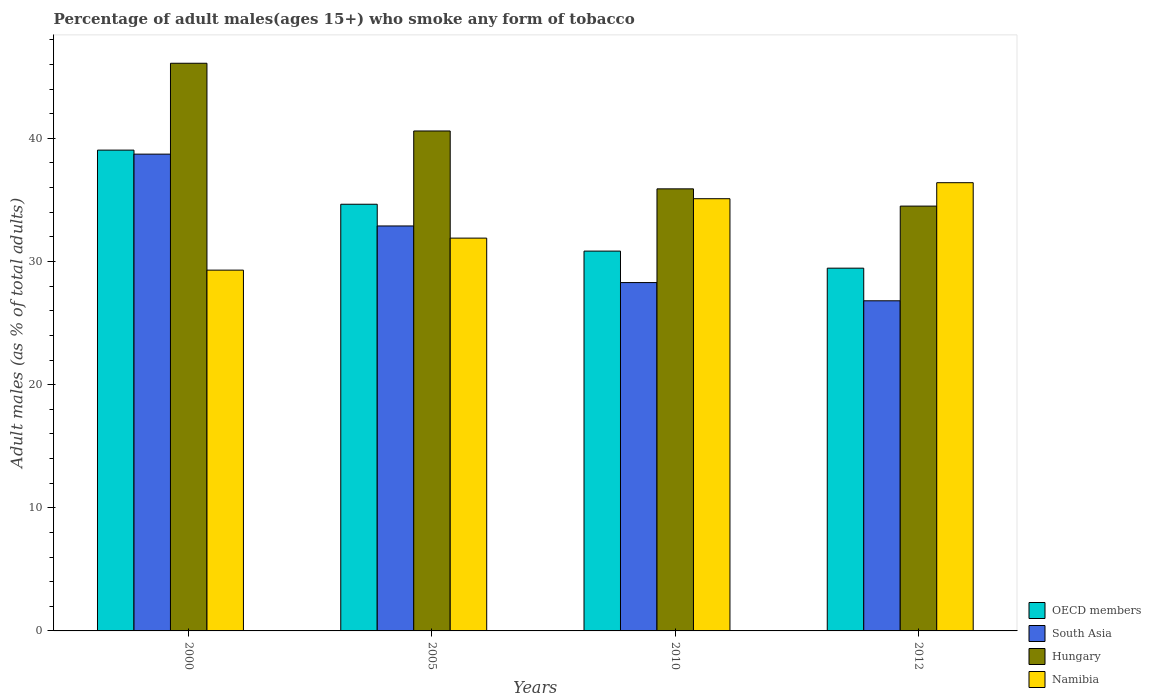Are the number of bars per tick equal to the number of legend labels?
Make the answer very short. Yes. How many bars are there on the 4th tick from the left?
Make the answer very short. 4. How many bars are there on the 3rd tick from the right?
Make the answer very short. 4. What is the label of the 2nd group of bars from the left?
Ensure brevity in your answer.  2005. In how many cases, is the number of bars for a given year not equal to the number of legend labels?
Offer a terse response. 0. What is the percentage of adult males who smoke in South Asia in 2012?
Your answer should be very brief. 26.81. Across all years, what is the maximum percentage of adult males who smoke in Namibia?
Make the answer very short. 36.4. Across all years, what is the minimum percentage of adult males who smoke in Hungary?
Provide a succinct answer. 34.5. In which year was the percentage of adult males who smoke in OECD members maximum?
Offer a terse response. 2000. What is the total percentage of adult males who smoke in Namibia in the graph?
Give a very brief answer. 132.7. What is the difference between the percentage of adult males who smoke in Hungary in 2010 and that in 2012?
Give a very brief answer. 1.4. What is the difference between the percentage of adult males who smoke in OECD members in 2000 and the percentage of adult males who smoke in Namibia in 2005?
Offer a very short reply. 7.15. What is the average percentage of adult males who smoke in OECD members per year?
Give a very brief answer. 33.5. In the year 2012, what is the difference between the percentage of adult males who smoke in South Asia and percentage of adult males who smoke in Hungary?
Provide a short and direct response. -7.69. In how many years, is the percentage of adult males who smoke in South Asia greater than 22 %?
Your answer should be very brief. 4. What is the ratio of the percentage of adult males who smoke in Hungary in 2010 to that in 2012?
Offer a very short reply. 1.04. Is the percentage of adult males who smoke in OECD members in 2000 less than that in 2012?
Provide a succinct answer. No. What is the difference between the highest and the second highest percentage of adult males who smoke in OECD members?
Your answer should be compact. 4.4. What is the difference between the highest and the lowest percentage of adult males who smoke in South Asia?
Offer a very short reply. 11.91. Is the sum of the percentage of adult males who smoke in OECD members in 2005 and 2012 greater than the maximum percentage of adult males who smoke in Hungary across all years?
Provide a succinct answer. Yes. Is it the case that in every year, the sum of the percentage of adult males who smoke in OECD members and percentage of adult males who smoke in South Asia is greater than the sum of percentage of adult males who smoke in Namibia and percentage of adult males who smoke in Hungary?
Your answer should be compact. No. What does the 3rd bar from the left in 2000 represents?
Your response must be concise. Hungary. What does the 3rd bar from the right in 2010 represents?
Your answer should be very brief. South Asia. How many bars are there?
Your response must be concise. 16. What is the difference between two consecutive major ticks on the Y-axis?
Give a very brief answer. 10. Does the graph contain any zero values?
Give a very brief answer. No. What is the title of the graph?
Provide a succinct answer. Percentage of adult males(ages 15+) who smoke any form of tobacco. What is the label or title of the X-axis?
Your answer should be compact. Years. What is the label or title of the Y-axis?
Offer a terse response. Adult males (as % of total adults). What is the Adult males (as % of total adults) in OECD members in 2000?
Provide a succinct answer. 39.05. What is the Adult males (as % of total adults) of South Asia in 2000?
Keep it short and to the point. 38.72. What is the Adult males (as % of total adults) of Hungary in 2000?
Provide a succinct answer. 46.1. What is the Adult males (as % of total adults) of Namibia in 2000?
Give a very brief answer. 29.3. What is the Adult males (as % of total adults) of OECD members in 2005?
Provide a short and direct response. 34.65. What is the Adult males (as % of total adults) in South Asia in 2005?
Your answer should be compact. 32.89. What is the Adult males (as % of total adults) in Hungary in 2005?
Your response must be concise. 40.6. What is the Adult males (as % of total adults) of Namibia in 2005?
Offer a terse response. 31.9. What is the Adult males (as % of total adults) of OECD members in 2010?
Offer a terse response. 30.85. What is the Adult males (as % of total adults) in South Asia in 2010?
Offer a very short reply. 28.29. What is the Adult males (as % of total adults) of Hungary in 2010?
Make the answer very short. 35.9. What is the Adult males (as % of total adults) of Namibia in 2010?
Offer a very short reply. 35.1. What is the Adult males (as % of total adults) in OECD members in 2012?
Ensure brevity in your answer.  29.46. What is the Adult males (as % of total adults) in South Asia in 2012?
Keep it short and to the point. 26.81. What is the Adult males (as % of total adults) in Hungary in 2012?
Offer a very short reply. 34.5. What is the Adult males (as % of total adults) of Namibia in 2012?
Your answer should be very brief. 36.4. Across all years, what is the maximum Adult males (as % of total adults) of OECD members?
Keep it short and to the point. 39.05. Across all years, what is the maximum Adult males (as % of total adults) of South Asia?
Provide a short and direct response. 38.72. Across all years, what is the maximum Adult males (as % of total adults) in Hungary?
Your answer should be compact. 46.1. Across all years, what is the maximum Adult males (as % of total adults) in Namibia?
Give a very brief answer. 36.4. Across all years, what is the minimum Adult males (as % of total adults) of OECD members?
Offer a very short reply. 29.46. Across all years, what is the minimum Adult males (as % of total adults) of South Asia?
Offer a very short reply. 26.81. Across all years, what is the minimum Adult males (as % of total adults) of Hungary?
Make the answer very short. 34.5. Across all years, what is the minimum Adult males (as % of total adults) of Namibia?
Your response must be concise. 29.3. What is the total Adult males (as % of total adults) of OECD members in the graph?
Provide a succinct answer. 134. What is the total Adult males (as % of total adults) of South Asia in the graph?
Ensure brevity in your answer.  126.71. What is the total Adult males (as % of total adults) in Hungary in the graph?
Your answer should be compact. 157.1. What is the total Adult males (as % of total adults) of Namibia in the graph?
Offer a terse response. 132.7. What is the difference between the Adult males (as % of total adults) in OECD members in 2000 and that in 2005?
Provide a short and direct response. 4.4. What is the difference between the Adult males (as % of total adults) of South Asia in 2000 and that in 2005?
Ensure brevity in your answer.  5.83. What is the difference between the Adult males (as % of total adults) in Namibia in 2000 and that in 2005?
Your response must be concise. -2.6. What is the difference between the Adult males (as % of total adults) of OECD members in 2000 and that in 2010?
Your answer should be compact. 8.2. What is the difference between the Adult males (as % of total adults) of South Asia in 2000 and that in 2010?
Make the answer very short. 10.43. What is the difference between the Adult males (as % of total adults) of OECD members in 2000 and that in 2012?
Ensure brevity in your answer.  9.59. What is the difference between the Adult males (as % of total adults) in South Asia in 2000 and that in 2012?
Keep it short and to the point. 11.91. What is the difference between the Adult males (as % of total adults) of Hungary in 2000 and that in 2012?
Give a very brief answer. 11.6. What is the difference between the Adult males (as % of total adults) in OECD members in 2005 and that in 2010?
Make the answer very short. 3.81. What is the difference between the Adult males (as % of total adults) in South Asia in 2005 and that in 2010?
Your answer should be very brief. 4.6. What is the difference between the Adult males (as % of total adults) of Hungary in 2005 and that in 2010?
Keep it short and to the point. 4.7. What is the difference between the Adult males (as % of total adults) in OECD members in 2005 and that in 2012?
Ensure brevity in your answer.  5.19. What is the difference between the Adult males (as % of total adults) in South Asia in 2005 and that in 2012?
Offer a terse response. 6.08. What is the difference between the Adult males (as % of total adults) in Hungary in 2005 and that in 2012?
Offer a very short reply. 6.1. What is the difference between the Adult males (as % of total adults) in OECD members in 2010 and that in 2012?
Your answer should be very brief. 1.39. What is the difference between the Adult males (as % of total adults) of South Asia in 2010 and that in 2012?
Provide a succinct answer. 1.48. What is the difference between the Adult males (as % of total adults) in Namibia in 2010 and that in 2012?
Keep it short and to the point. -1.3. What is the difference between the Adult males (as % of total adults) in OECD members in 2000 and the Adult males (as % of total adults) in South Asia in 2005?
Your answer should be compact. 6.16. What is the difference between the Adult males (as % of total adults) of OECD members in 2000 and the Adult males (as % of total adults) of Hungary in 2005?
Make the answer very short. -1.55. What is the difference between the Adult males (as % of total adults) in OECD members in 2000 and the Adult males (as % of total adults) in Namibia in 2005?
Your answer should be compact. 7.15. What is the difference between the Adult males (as % of total adults) in South Asia in 2000 and the Adult males (as % of total adults) in Hungary in 2005?
Provide a short and direct response. -1.88. What is the difference between the Adult males (as % of total adults) in South Asia in 2000 and the Adult males (as % of total adults) in Namibia in 2005?
Keep it short and to the point. 6.82. What is the difference between the Adult males (as % of total adults) in Hungary in 2000 and the Adult males (as % of total adults) in Namibia in 2005?
Provide a succinct answer. 14.2. What is the difference between the Adult males (as % of total adults) of OECD members in 2000 and the Adult males (as % of total adults) of South Asia in 2010?
Provide a succinct answer. 10.76. What is the difference between the Adult males (as % of total adults) of OECD members in 2000 and the Adult males (as % of total adults) of Hungary in 2010?
Ensure brevity in your answer.  3.15. What is the difference between the Adult males (as % of total adults) in OECD members in 2000 and the Adult males (as % of total adults) in Namibia in 2010?
Provide a succinct answer. 3.95. What is the difference between the Adult males (as % of total adults) of South Asia in 2000 and the Adult males (as % of total adults) of Hungary in 2010?
Your answer should be compact. 2.82. What is the difference between the Adult males (as % of total adults) of South Asia in 2000 and the Adult males (as % of total adults) of Namibia in 2010?
Ensure brevity in your answer.  3.62. What is the difference between the Adult males (as % of total adults) in OECD members in 2000 and the Adult males (as % of total adults) in South Asia in 2012?
Offer a very short reply. 12.24. What is the difference between the Adult males (as % of total adults) in OECD members in 2000 and the Adult males (as % of total adults) in Hungary in 2012?
Your answer should be compact. 4.55. What is the difference between the Adult males (as % of total adults) in OECD members in 2000 and the Adult males (as % of total adults) in Namibia in 2012?
Keep it short and to the point. 2.65. What is the difference between the Adult males (as % of total adults) of South Asia in 2000 and the Adult males (as % of total adults) of Hungary in 2012?
Offer a very short reply. 4.22. What is the difference between the Adult males (as % of total adults) in South Asia in 2000 and the Adult males (as % of total adults) in Namibia in 2012?
Give a very brief answer. 2.32. What is the difference between the Adult males (as % of total adults) of OECD members in 2005 and the Adult males (as % of total adults) of South Asia in 2010?
Ensure brevity in your answer.  6.36. What is the difference between the Adult males (as % of total adults) in OECD members in 2005 and the Adult males (as % of total adults) in Hungary in 2010?
Offer a terse response. -1.25. What is the difference between the Adult males (as % of total adults) of OECD members in 2005 and the Adult males (as % of total adults) of Namibia in 2010?
Ensure brevity in your answer.  -0.45. What is the difference between the Adult males (as % of total adults) in South Asia in 2005 and the Adult males (as % of total adults) in Hungary in 2010?
Give a very brief answer. -3.01. What is the difference between the Adult males (as % of total adults) of South Asia in 2005 and the Adult males (as % of total adults) of Namibia in 2010?
Give a very brief answer. -2.21. What is the difference between the Adult males (as % of total adults) in OECD members in 2005 and the Adult males (as % of total adults) in South Asia in 2012?
Give a very brief answer. 7.84. What is the difference between the Adult males (as % of total adults) of OECD members in 2005 and the Adult males (as % of total adults) of Hungary in 2012?
Offer a terse response. 0.15. What is the difference between the Adult males (as % of total adults) of OECD members in 2005 and the Adult males (as % of total adults) of Namibia in 2012?
Ensure brevity in your answer.  -1.75. What is the difference between the Adult males (as % of total adults) in South Asia in 2005 and the Adult males (as % of total adults) in Hungary in 2012?
Your response must be concise. -1.61. What is the difference between the Adult males (as % of total adults) in South Asia in 2005 and the Adult males (as % of total adults) in Namibia in 2012?
Provide a short and direct response. -3.51. What is the difference between the Adult males (as % of total adults) of Hungary in 2005 and the Adult males (as % of total adults) of Namibia in 2012?
Make the answer very short. 4.2. What is the difference between the Adult males (as % of total adults) in OECD members in 2010 and the Adult males (as % of total adults) in South Asia in 2012?
Your answer should be compact. 4.04. What is the difference between the Adult males (as % of total adults) in OECD members in 2010 and the Adult males (as % of total adults) in Hungary in 2012?
Keep it short and to the point. -3.65. What is the difference between the Adult males (as % of total adults) of OECD members in 2010 and the Adult males (as % of total adults) of Namibia in 2012?
Your response must be concise. -5.55. What is the difference between the Adult males (as % of total adults) in South Asia in 2010 and the Adult males (as % of total adults) in Hungary in 2012?
Offer a very short reply. -6.21. What is the difference between the Adult males (as % of total adults) in South Asia in 2010 and the Adult males (as % of total adults) in Namibia in 2012?
Offer a terse response. -8.11. What is the average Adult males (as % of total adults) in OECD members per year?
Your response must be concise. 33.5. What is the average Adult males (as % of total adults) of South Asia per year?
Your answer should be very brief. 31.68. What is the average Adult males (as % of total adults) in Hungary per year?
Your response must be concise. 39.27. What is the average Adult males (as % of total adults) of Namibia per year?
Your answer should be very brief. 33.17. In the year 2000, what is the difference between the Adult males (as % of total adults) of OECD members and Adult males (as % of total adults) of South Asia?
Keep it short and to the point. 0.33. In the year 2000, what is the difference between the Adult males (as % of total adults) in OECD members and Adult males (as % of total adults) in Hungary?
Give a very brief answer. -7.05. In the year 2000, what is the difference between the Adult males (as % of total adults) in OECD members and Adult males (as % of total adults) in Namibia?
Your answer should be very brief. 9.75. In the year 2000, what is the difference between the Adult males (as % of total adults) in South Asia and Adult males (as % of total adults) in Hungary?
Make the answer very short. -7.38. In the year 2000, what is the difference between the Adult males (as % of total adults) in South Asia and Adult males (as % of total adults) in Namibia?
Make the answer very short. 9.42. In the year 2000, what is the difference between the Adult males (as % of total adults) in Hungary and Adult males (as % of total adults) in Namibia?
Your response must be concise. 16.8. In the year 2005, what is the difference between the Adult males (as % of total adults) in OECD members and Adult males (as % of total adults) in South Asia?
Make the answer very short. 1.76. In the year 2005, what is the difference between the Adult males (as % of total adults) of OECD members and Adult males (as % of total adults) of Hungary?
Provide a succinct answer. -5.95. In the year 2005, what is the difference between the Adult males (as % of total adults) in OECD members and Adult males (as % of total adults) in Namibia?
Offer a very short reply. 2.75. In the year 2005, what is the difference between the Adult males (as % of total adults) of South Asia and Adult males (as % of total adults) of Hungary?
Keep it short and to the point. -7.71. In the year 2005, what is the difference between the Adult males (as % of total adults) in South Asia and Adult males (as % of total adults) in Namibia?
Give a very brief answer. 0.99. In the year 2010, what is the difference between the Adult males (as % of total adults) of OECD members and Adult males (as % of total adults) of South Asia?
Provide a short and direct response. 2.56. In the year 2010, what is the difference between the Adult males (as % of total adults) in OECD members and Adult males (as % of total adults) in Hungary?
Keep it short and to the point. -5.05. In the year 2010, what is the difference between the Adult males (as % of total adults) of OECD members and Adult males (as % of total adults) of Namibia?
Give a very brief answer. -4.25. In the year 2010, what is the difference between the Adult males (as % of total adults) of South Asia and Adult males (as % of total adults) of Hungary?
Provide a succinct answer. -7.61. In the year 2010, what is the difference between the Adult males (as % of total adults) of South Asia and Adult males (as % of total adults) of Namibia?
Provide a succinct answer. -6.81. In the year 2012, what is the difference between the Adult males (as % of total adults) of OECD members and Adult males (as % of total adults) of South Asia?
Your answer should be compact. 2.65. In the year 2012, what is the difference between the Adult males (as % of total adults) in OECD members and Adult males (as % of total adults) in Hungary?
Ensure brevity in your answer.  -5.04. In the year 2012, what is the difference between the Adult males (as % of total adults) in OECD members and Adult males (as % of total adults) in Namibia?
Provide a short and direct response. -6.94. In the year 2012, what is the difference between the Adult males (as % of total adults) in South Asia and Adult males (as % of total adults) in Hungary?
Give a very brief answer. -7.69. In the year 2012, what is the difference between the Adult males (as % of total adults) in South Asia and Adult males (as % of total adults) in Namibia?
Your response must be concise. -9.59. In the year 2012, what is the difference between the Adult males (as % of total adults) of Hungary and Adult males (as % of total adults) of Namibia?
Your answer should be very brief. -1.9. What is the ratio of the Adult males (as % of total adults) in OECD members in 2000 to that in 2005?
Offer a very short reply. 1.13. What is the ratio of the Adult males (as % of total adults) of South Asia in 2000 to that in 2005?
Make the answer very short. 1.18. What is the ratio of the Adult males (as % of total adults) in Hungary in 2000 to that in 2005?
Offer a very short reply. 1.14. What is the ratio of the Adult males (as % of total adults) in Namibia in 2000 to that in 2005?
Ensure brevity in your answer.  0.92. What is the ratio of the Adult males (as % of total adults) in OECD members in 2000 to that in 2010?
Keep it short and to the point. 1.27. What is the ratio of the Adult males (as % of total adults) of South Asia in 2000 to that in 2010?
Offer a very short reply. 1.37. What is the ratio of the Adult males (as % of total adults) in Hungary in 2000 to that in 2010?
Offer a very short reply. 1.28. What is the ratio of the Adult males (as % of total adults) of Namibia in 2000 to that in 2010?
Provide a succinct answer. 0.83. What is the ratio of the Adult males (as % of total adults) of OECD members in 2000 to that in 2012?
Provide a short and direct response. 1.33. What is the ratio of the Adult males (as % of total adults) of South Asia in 2000 to that in 2012?
Give a very brief answer. 1.44. What is the ratio of the Adult males (as % of total adults) in Hungary in 2000 to that in 2012?
Your answer should be very brief. 1.34. What is the ratio of the Adult males (as % of total adults) in Namibia in 2000 to that in 2012?
Keep it short and to the point. 0.8. What is the ratio of the Adult males (as % of total adults) of OECD members in 2005 to that in 2010?
Keep it short and to the point. 1.12. What is the ratio of the Adult males (as % of total adults) in South Asia in 2005 to that in 2010?
Your response must be concise. 1.16. What is the ratio of the Adult males (as % of total adults) in Hungary in 2005 to that in 2010?
Your answer should be compact. 1.13. What is the ratio of the Adult males (as % of total adults) of Namibia in 2005 to that in 2010?
Ensure brevity in your answer.  0.91. What is the ratio of the Adult males (as % of total adults) of OECD members in 2005 to that in 2012?
Your answer should be very brief. 1.18. What is the ratio of the Adult males (as % of total adults) of South Asia in 2005 to that in 2012?
Ensure brevity in your answer.  1.23. What is the ratio of the Adult males (as % of total adults) in Hungary in 2005 to that in 2012?
Your answer should be very brief. 1.18. What is the ratio of the Adult males (as % of total adults) of Namibia in 2005 to that in 2012?
Make the answer very short. 0.88. What is the ratio of the Adult males (as % of total adults) in OECD members in 2010 to that in 2012?
Your response must be concise. 1.05. What is the ratio of the Adult males (as % of total adults) of South Asia in 2010 to that in 2012?
Offer a very short reply. 1.06. What is the ratio of the Adult males (as % of total adults) of Hungary in 2010 to that in 2012?
Make the answer very short. 1.04. What is the ratio of the Adult males (as % of total adults) in Namibia in 2010 to that in 2012?
Keep it short and to the point. 0.96. What is the difference between the highest and the second highest Adult males (as % of total adults) in OECD members?
Keep it short and to the point. 4.4. What is the difference between the highest and the second highest Adult males (as % of total adults) of South Asia?
Your answer should be very brief. 5.83. What is the difference between the highest and the second highest Adult males (as % of total adults) in Namibia?
Offer a terse response. 1.3. What is the difference between the highest and the lowest Adult males (as % of total adults) of OECD members?
Offer a terse response. 9.59. What is the difference between the highest and the lowest Adult males (as % of total adults) of South Asia?
Ensure brevity in your answer.  11.91. 